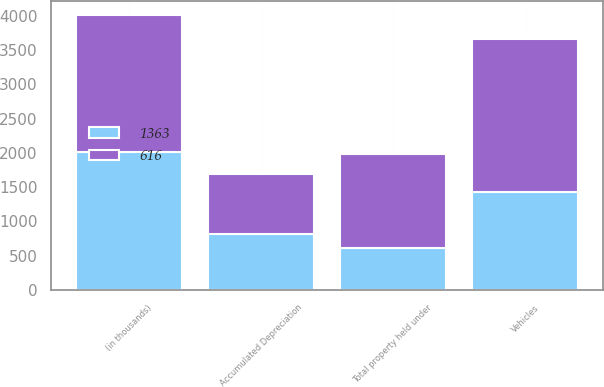Convert chart to OTSL. <chart><loc_0><loc_0><loc_500><loc_500><stacked_bar_chart><ecel><fcel>(in thousands)<fcel>Vehicles<fcel>Accumulated Depreciation<fcel>Total property held under<nl><fcel>1363<fcel>2006<fcel>1428<fcel>819<fcel>616<nl><fcel>616<fcel>2005<fcel>2234<fcel>871<fcel>1363<nl></chart> 